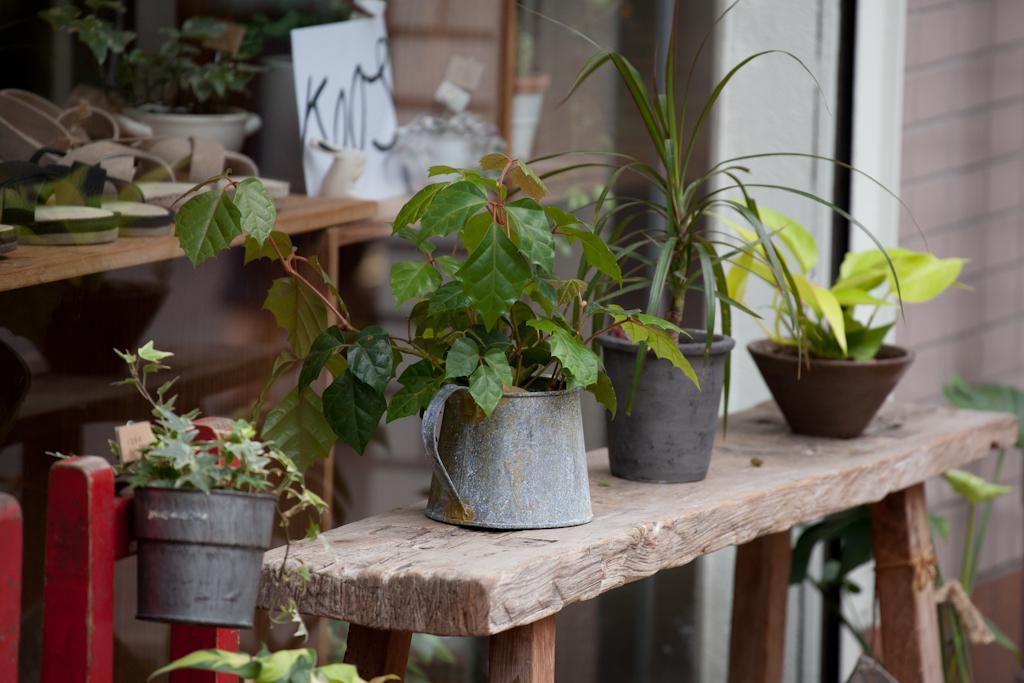Can you describe this image briefly? I can see three small flower pots placed on the wooden bench. And I can see another flower pot hanging to the red object. At background I can see a small table where some objects are placed on it. 